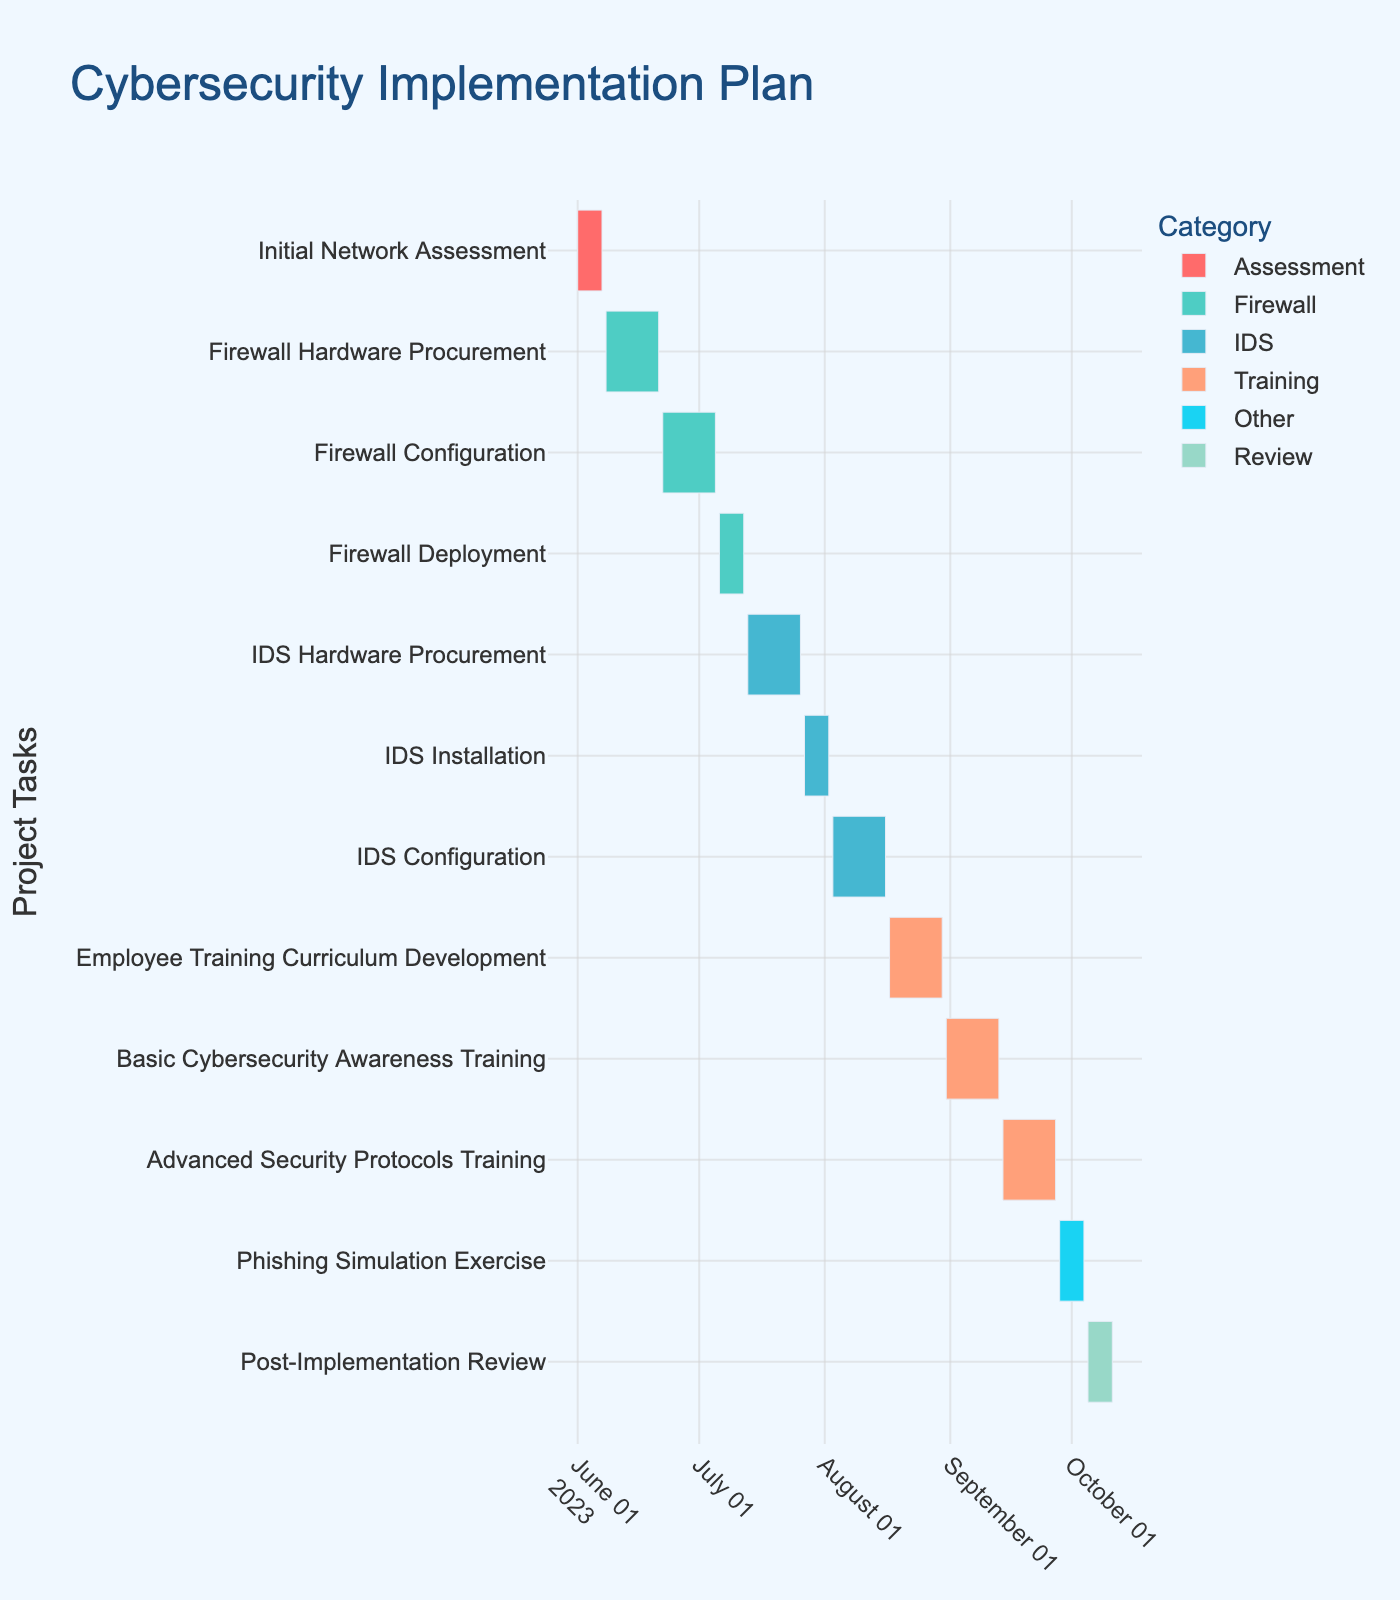What is the title of the Gantt Chart? The title of the Gantt Chart is typically displayed prominently at the top of the chart. In this case, it is given in the code as "Cybersecurity Implementation Plan."
Answer: Cybersecurity Implementation Plan How long is the Initial Network Assessment task? To find this, you look at the duration of the Initial Network Assessment task. Based on the data provided, the duration is given directly in the table as 7 days.
Answer: 7 days Which task takes the longest time to complete? From the Gantt Chart, you can see each task duration by inspecting the length of each bar. By comparing the durations, Firewall Hardware Procurement, Firewall Configuration, IDS Hardware Procurement, IDS Configuration, Employee Training Curriculum Development, Basic Cybersecurity Awareness Training, and Advanced Security Protocols Training all have the longest duration of 14 days each.
Answer: Several tasks are 14 days What are the start and end dates for the IDS Installation task? By tracking the IDS Installation task on the y-axis and then looking at the corresponding start and end points on the x-axis, you can determine that IDS Installation starts on July 27, 2023, and ends on August 2, 2023.
Answer: Starts: July 27, 2023, Ends: August 2, 2023 Which category has the most tasks? By counting the color-coded bars corresponding to different categories (Assessment, Firewall, IDS, Training, Review), the category with the most tasks is the Training category, which comprises four tasks.
Answer: Training What tasks are directly before and after the Firewall Deployment? To determine the tasks before and after Firewall Deployment, examine the order on the y-axis of the Gantt Chart. The task before Firewall Deployment is Firewall Configuration, and the task after is IDS Hardware Procurement.
Answer: Before: Firewall Configuration, After: IDS Hardware Procurement What is the total duration for all tasks combined? Sum up the duration of all tasks: 7 + 14 + 14 + 7 + 14 + 7 + 14 + 14 + 14 + 14 + 7 + 7 = 133 days.
Answer: 133 days How many tasks are less than 10 days long? By checking the duration of each task, the tasks with durations less than 10 days are Initial Network Assessment (7 days), Firewall Deployment (7 days), IDS Installation (7 days), Phishing Simulation Exercise (7 days), and Post-Implementation Review (7 days). There are 5 such tasks.
Answer: 5 tasks When does the entire cybersecurity implementation plan start and end? Refer to the start date of the earliest task and the end date of the latest task. The earliest start date is June 1, 2023 (Initial Network Assessment), and the latest end date is October 11, 2023 (Post-Implementation Review).
Answer: Starts: June 1, 2023, Ends: October 11, 2023 Which milestone occurs first according to the chart? Milestones are marked with star symbols. Compare the end dates of the milestone tasks: Firewall Deployment ends on July 12, 2023; IDS Configuration ends on August 16, 2023; Phishing Simulation Exercise ends on October 4, 2023; Post-Implementation Review ends on October 11, 2023. The first milestone is the end of Firewall Deployment.
Answer: Firewall Deployment 